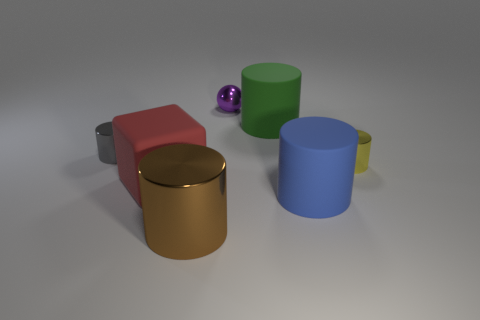There is a tiny cylinder that is to the right of the rubber cube; does it have the same color as the cube?
Make the answer very short. No. What color is the big shiny thing that is the same shape as the tiny yellow object?
Your answer should be compact. Brown. How many large things are red rubber things or gray metallic cylinders?
Ensure brevity in your answer.  1. There is a shiny cylinder to the left of the brown shiny cylinder; what is its size?
Provide a succinct answer. Small. Are there any tiny metallic objects of the same color as the matte cube?
Your response must be concise. No. Does the large metallic thing have the same color as the tiny shiny sphere?
Your response must be concise. No. There is a big matte cylinder that is in front of the tiny yellow metal cylinder; what number of big blue cylinders are on the right side of it?
Give a very brief answer. 0. What number of small brown blocks have the same material as the large green object?
Offer a very short reply. 0. Are there any small things in front of the yellow shiny thing?
Offer a very short reply. No. The shiny sphere that is the same size as the yellow thing is what color?
Your response must be concise. Purple. 